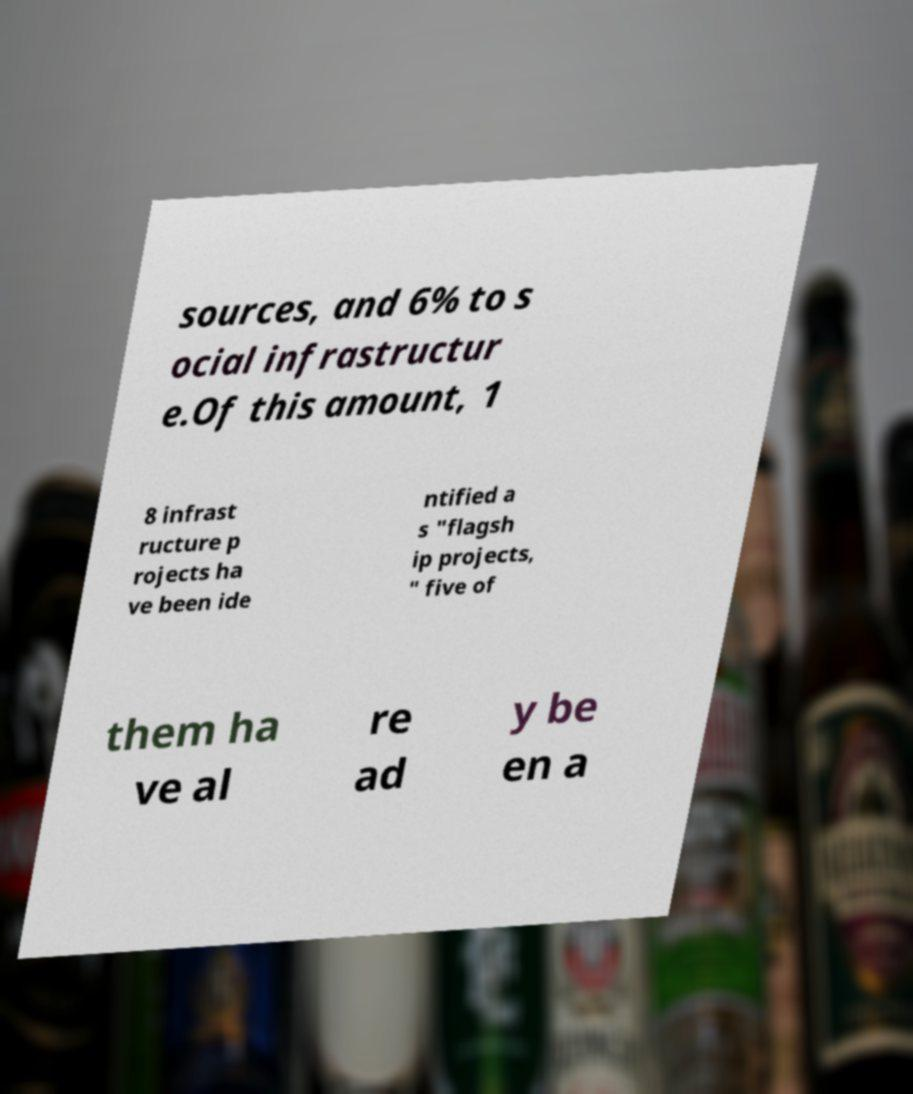Could you assist in decoding the text presented in this image and type it out clearly? sources, and 6% to s ocial infrastructur e.Of this amount, 1 8 infrast ructure p rojects ha ve been ide ntified a s "flagsh ip projects, " five of them ha ve al re ad y be en a 